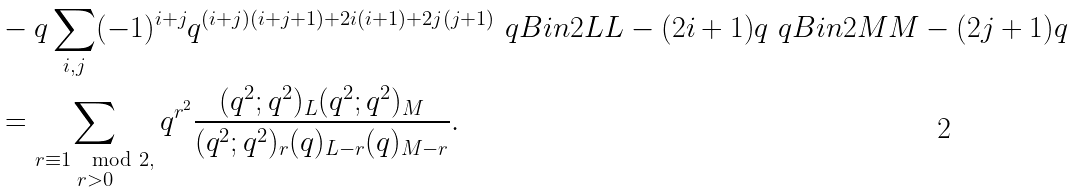Convert formula to latex. <formula><loc_0><loc_0><loc_500><loc_500>& - q \sum _ { i , j } ( - 1 ) ^ { i + j } q ^ { ( i + j ) ( i + j + 1 ) + 2 i ( i + 1 ) + 2 j ( j + 1 ) } \ q B i n { 2 L } { L - ( 2 i + 1 ) } { q } \ q B i n { 2 M } { M - ( 2 j + 1 ) } { q } \\ & = \sum _ { \substack { r \equiv 1 \mod 2 , \\ r > 0 } } q ^ { r ^ { 2 } } \frac { ( q ^ { 2 } ; q ^ { 2 } ) _ { L } ( q ^ { 2 } ; q ^ { 2 } ) _ { M } } { ( q ^ { 2 } ; q ^ { 2 } ) _ { r } ( q ) _ { L - r } ( q ) _ { M - r } } .</formula> 